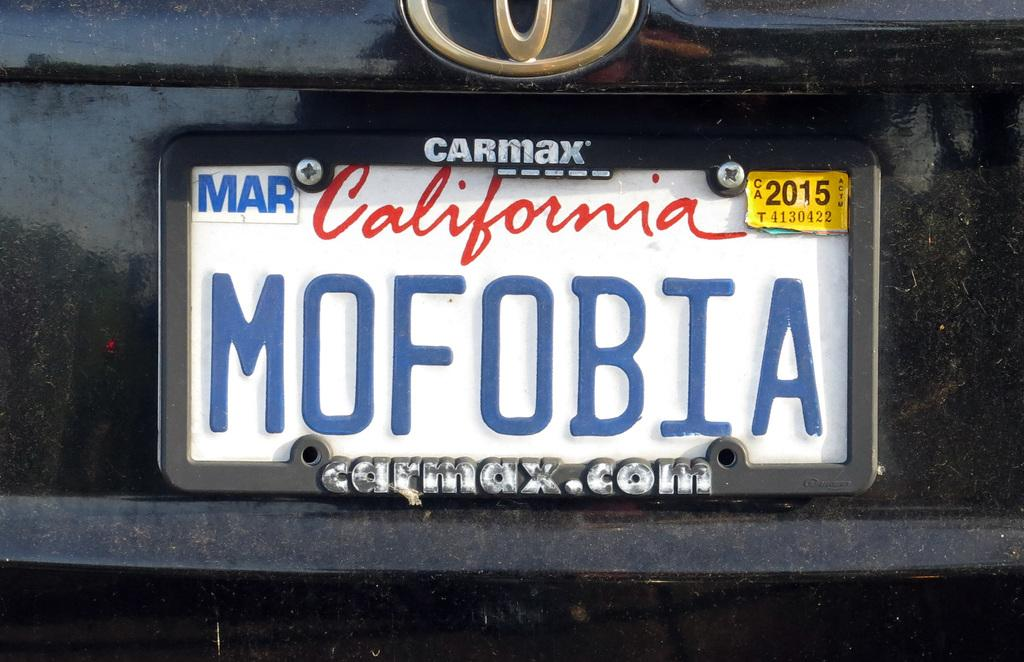<image>
Summarize the visual content of the image. White California license plate which says MOFOBIA on it. 